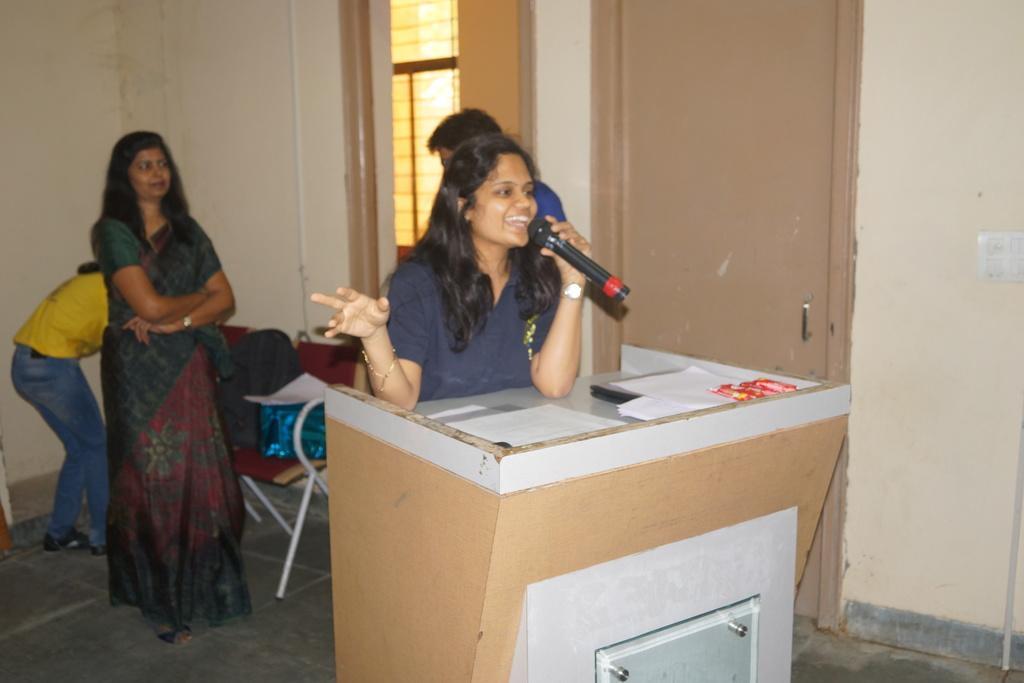Please provide a concise description of this image. In the center of the image we can see a woman standing near a speaker stand containing some papers on it. She is holding a mic. On the backside we can see some people standing on the floor, a chair with bag and papers on it. We can also see a wall, pipe, window, door and a switch board. 